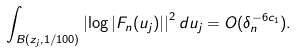Convert formula to latex. <formula><loc_0><loc_0><loc_500><loc_500>\int _ { B ( z _ { j } , 1 / 1 0 0 ) } \left | \log | F _ { n } ( u _ { j } ) | \right | ^ { 2 } d u _ { j } = O ( \delta _ { n } ^ { - 6 c _ { 1 } } ) .</formula> 